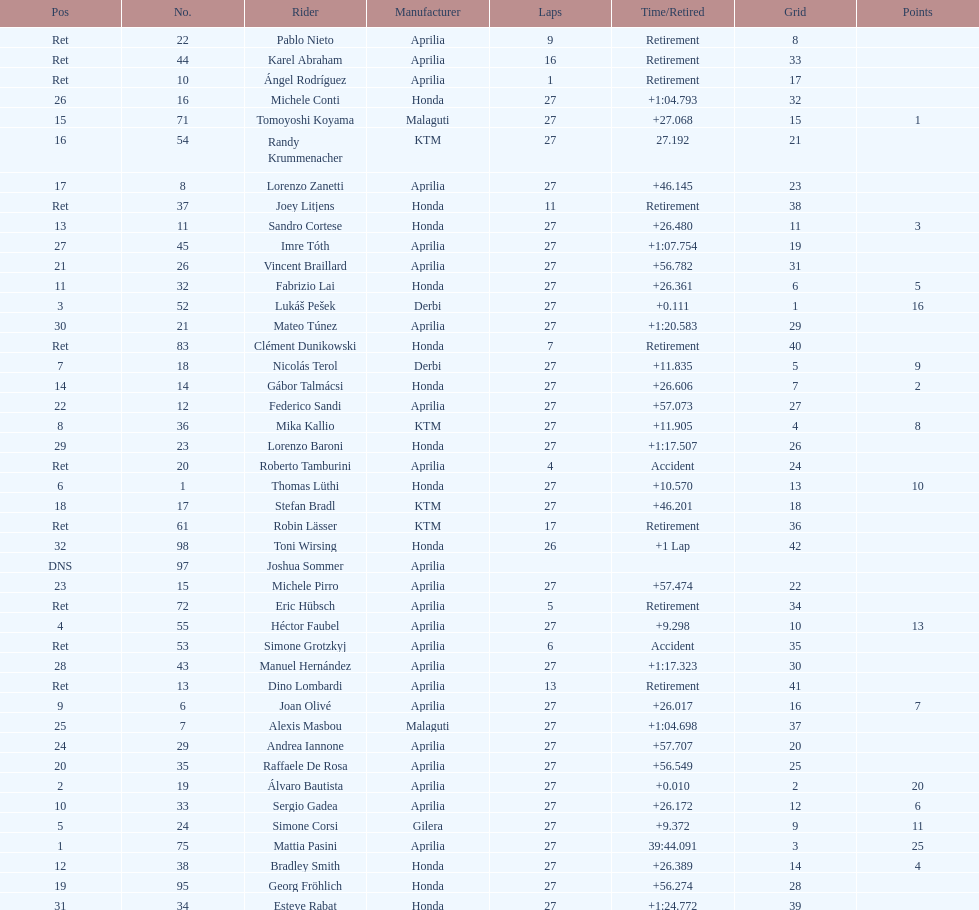Who placed higher, bradl or gadea? Sergio Gadea. Could you help me parse every detail presented in this table? {'header': ['Pos', 'No.', 'Rider', 'Manufacturer', 'Laps', 'Time/Retired', 'Grid', 'Points'], 'rows': [['Ret', '22', 'Pablo Nieto', 'Aprilia', '9', 'Retirement', '8', ''], ['Ret', '44', 'Karel Abraham', 'Aprilia', '16', 'Retirement', '33', ''], ['Ret', '10', 'Ángel Rodríguez', 'Aprilia', '1', 'Retirement', '17', ''], ['26', '16', 'Michele Conti', 'Honda', '27', '+1:04.793', '32', ''], ['15', '71', 'Tomoyoshi Koyama', 'Malaguti', '27', '+27.068', '15', '1'], ['16', '54', 'Randy Krummenacher', 'KTM', '27', '27.192', '21', ''], ['17', '8', 'Lorenzo Zanetti', 'Aprilia', '27', '+46.145', '23', ''], ['Ret', '37', 'Joey Litjens', 'Honda', '11', 'Retirement', '38', ''], ['13', '11', 'Sandro Cortese', 'Honda', '27', '+26.480', '11', '3'], ['27', '45', 'Imre Tóth', 'Aprilia', '27', '+1:07.754', '19', ''], ['21', '26', 'Vincent Braillard', 'Aprilia', '27', '+56.782', '31', ''], ['11', '32', 'Fabrizio Lai', 'Honda', '27', '+26.361', '6', '5'], ['3', '52', 'Lukáš Pešek', 'Derbi', '27', '+0.111', '1', '16'], ['30', '21', 'Mateo Túnez', 'Aprilia', '27', '+1:20.583', '29', ''], ['Ret', '83', 'Clément Dunikowski', 'Honda', '7', 'Retirement', '40', ''], ['7', '18', 'Nicolás Terol', 'Derbi', '27', '+11.835', '5', '9'], ['14', '14', 'Gábor Talmácsi', 'Honda', '27', '+26.606', '7', '2'], ['22', '12', 'Federico Sandi', 'Aprilia', '27', '+57.073', '27', ''], ['8', '36', 'Mika Kallio', 'KTM', '27', '+11.905', '4', '8'], ['29', '23', 'Lorenzo Baroni', 'Honda', '27', '+1:17.507', '26', ''], ['Ret', '20', 'Roberto Tamburini', 'Aprilia', '4', 'Accident', '24', ''], ['6', '1', 'Thomas Lüthi', 'Honda', '27', '+10.570', '13', '10'], ['18', '17', 'Stefan Bradl', 'KTM', '27', '+46.201', '18', ''], ['Ret', '61', 'Robin Lässer', 'KTM', '17', 'Retirement', '36', ''], ['32', '98', 'Toni Wirsing', 'Honda', '26', '+1 Lap', '42', ''], ['DNS', '97', 'Joshua Sommer', 'Aprilia', '', '', '', ''], ['23', '15', 'Michele Pirro', 'Aprilia', '27', '+57.474', '22', ''], ['Ret', '72', 'Eric Hübsch', 'Aprilia', '5', 'Retirement', '34', ''], ['4', '55', 'Héctor Faubel', 'Aprilia', '27', '+9.298', '10', '13'], ['Ret', '53', 'Simone Grotzkyj', 'Aprilia', '6', 'Accident', '35', ''], ['28', '43', 'Manuel Hernández', 'Aprilia', '27', '+1:17.323', '30', ''], ['Ret', '13', 'Dino Lombardi', 'Aprilia', '13', 'Retirement', '41', ''], ['9', '6', 'Joan Olivé', 'Aprilia', '27', '+26.017', '16', '7'], ['25', '7', 'Alexis Masbou', 'Malaguti', '27', '+1:04.698', '37', ''], ['24', '29', 'Andrea Iannone', 'Aprilia', '27', '+57.707', '20', ''], ['20', '35', 'Raffaele De Rosa', 'Aprilia', '27', '+56.549', '25', ''], ['2', '19', 'Álvaro Bautista', 'Aprilia', '27', '+0.010', '2', '20'], ['10', '33', 'Sergio Gadea', 'Aprilia', '27', '+26.172', '12', '6'], ['5', '24', 'Simone Corsi', 'Gilera', '27', '+9.372', '9', '11'], ['1', '75', 'Mattia Pasini', 'Aprilia', '27', '39:44.091', '3', '25'], ['12', '38', 'Bradley Smith', 'Honda', '27', '+26.389', '14', '4'], ['19', '95', 'Georg Fröhlich', 'Honda', '27', '+56.274', '28', ''], ['31', '34', 'Esteve Rabat', 'Honda', '27', '+1:24.772', '39', '']]} 